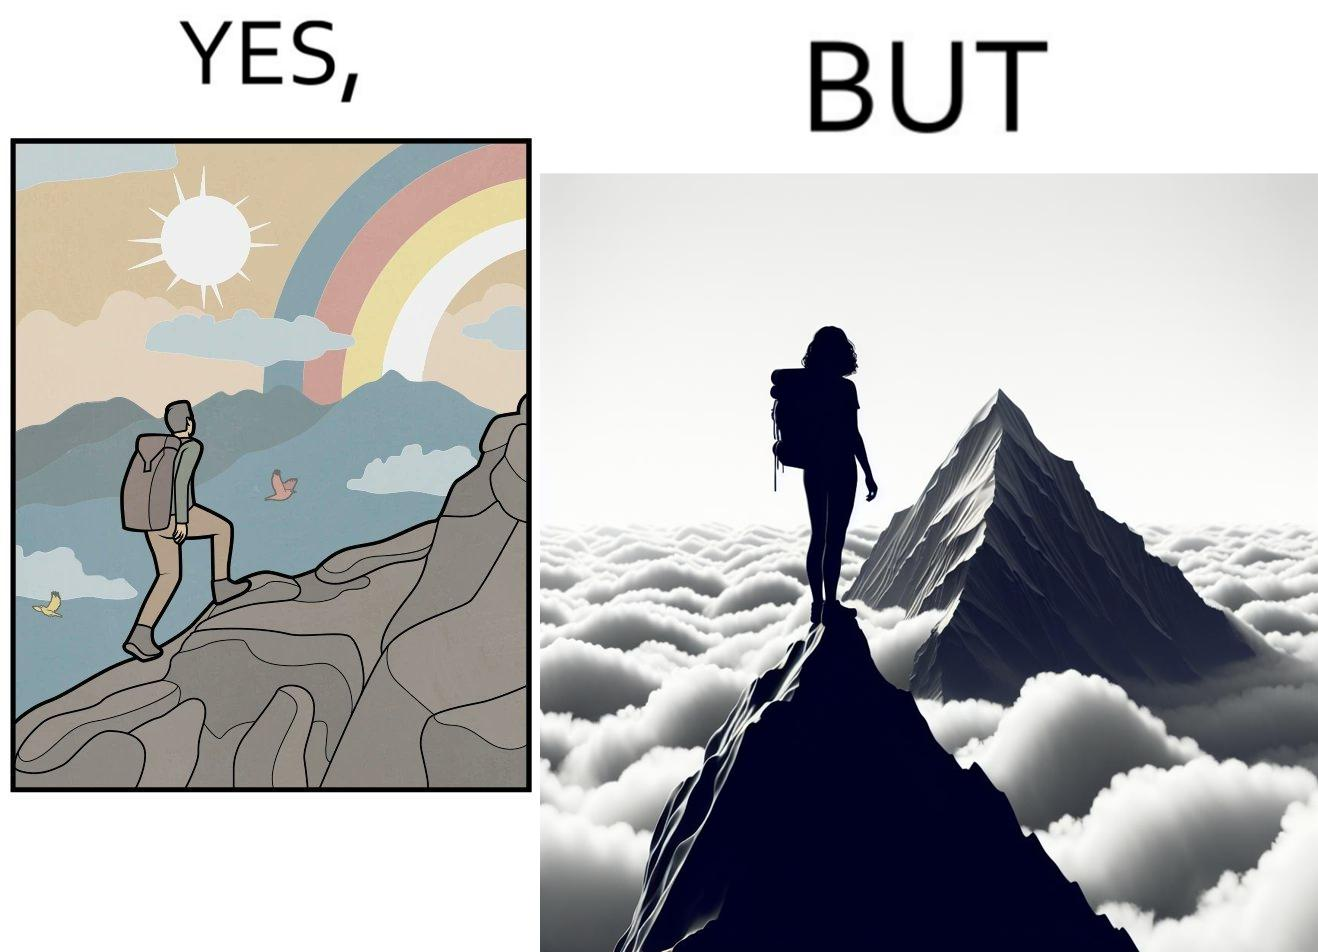What does this image depict? The image is ironic, because the mountaineer climbs up the mountain to view the world from the peak but due to so much cloud, at the top, nothing is visible whereas he was able to witness some awesome views while climbing up the mountain 